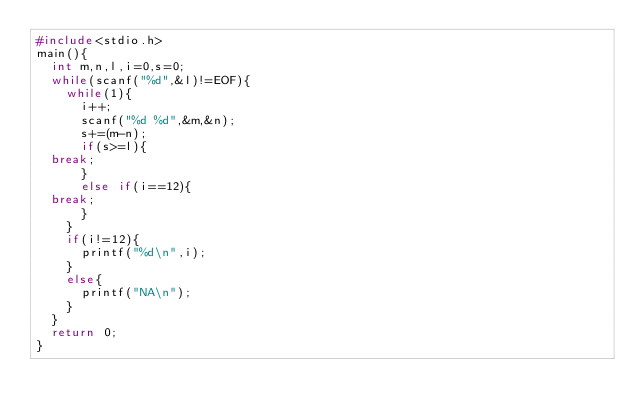Convert code to text. <code><loc_0><loc_0><loc_500><loc_500><_C_>#include<stdio.h>
main(){
  int m,n,l,i=0,s=0;
  while(scanf("%d",&l)!=EOF){
    while(1){
      i++;
      scanf("%d %d",&m,&n);
      s+=(m-n);
      if(s>=l){
	break;
      }
      else if(i==12){
	break;
      }
    }
    if(i!=12){
      printf("%d\n",i);
    }
    else{
      printf("NA\n");
    }
  }
  return 0;
}</code> 